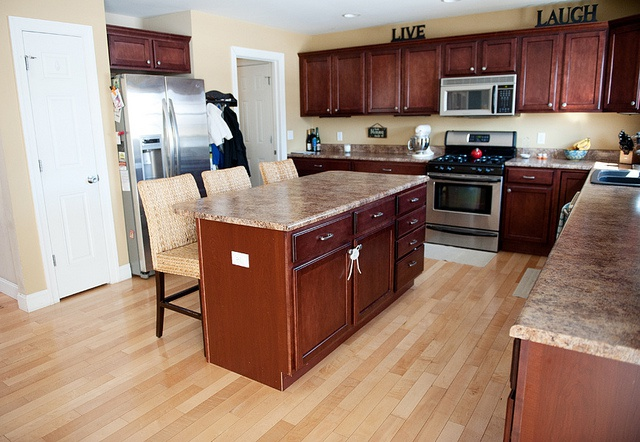Describe the objects in this image and their specific colors. I can see dining table in tan, maroon, darkgray, black, and gray tones, refrigerator in tan, white, darkgray, gray, and lightblue tones, oven in tan, black, gray, darkgray, and maroon tones, chair in tan, beige, and black tones, and microwave in tan, gray, darkgray, black, and lightgray tones in this image. 